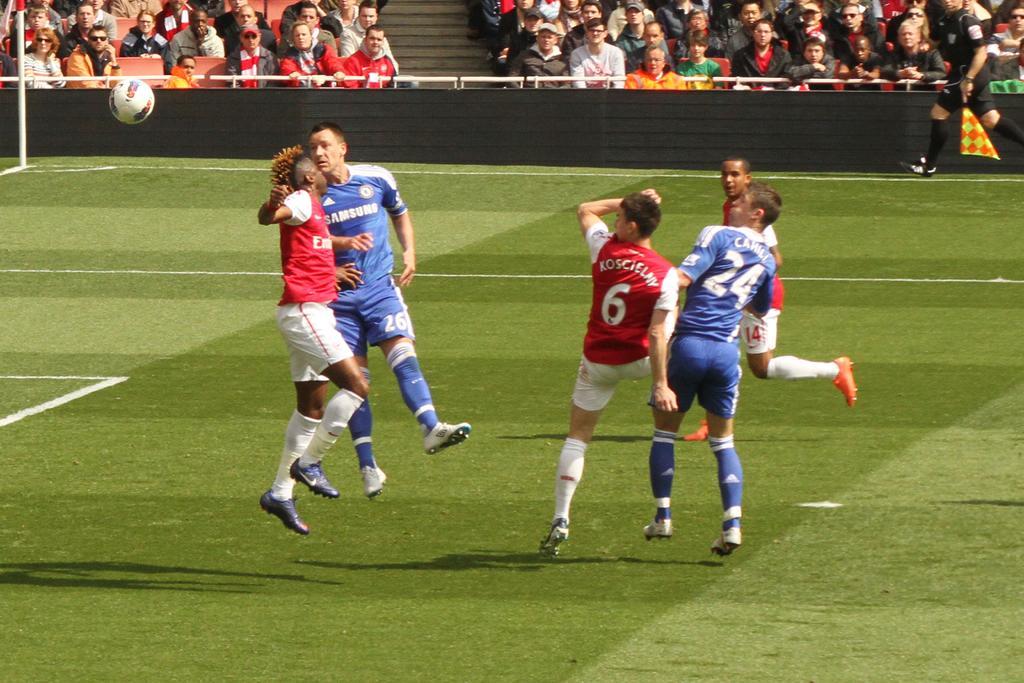Describe this image in one or two sentences. This is the picture of a stadium. In the foreground there are group of people jumping and there is a person running. At the back there are group of people sitting on the chairs. On the left side of the image there is a ball in the air and there is a pole. On the right side of the image there is a person holding the flag and running. At the back there is a hoarding and there is a staircase. At the bottom there is grass. 